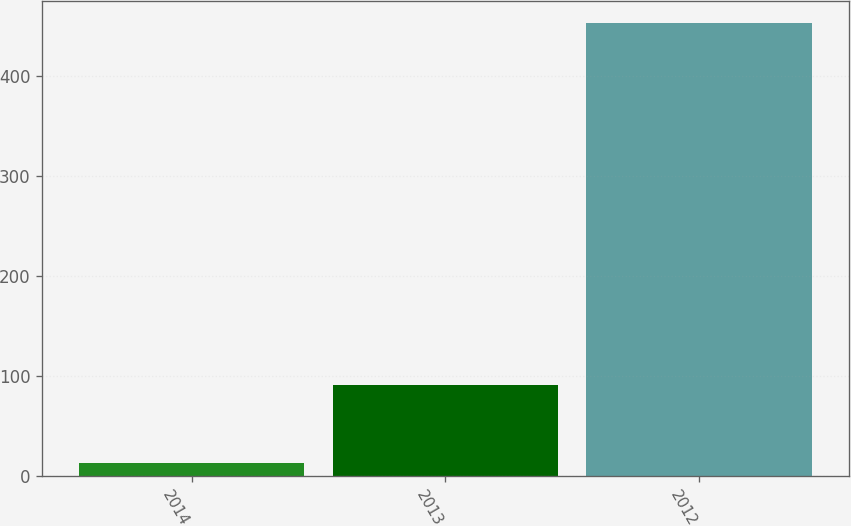Convert chart to OTSL. <chart><loc_0><loc_0><loc_500><loc_500><bar_chart><fcel>2014<fcel>2013<fcel>2012<nl><fcel>13<fcel>91<fcel>453<nl></chart> 